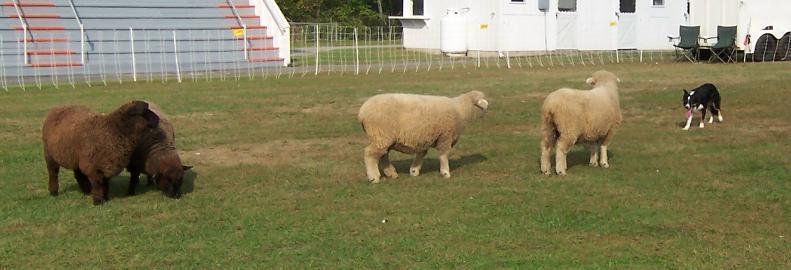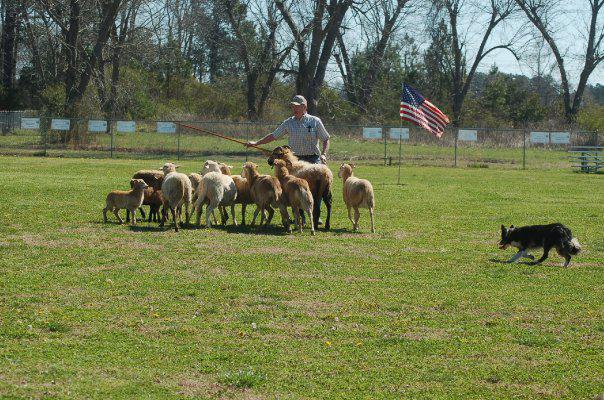The first image is the image on the left, the second image is the image on the right. Analyze the images presented: Is the assertion "The human in one of the images is wearing a baseball cap." valid? Answer yes or no. Yes. The first image is the image on the left, the second image is the image on the right. Examine the images to the left and right. Is the description "Pictures contain a black dog herding sheep." accurate? Answer yes or no. Yes. 